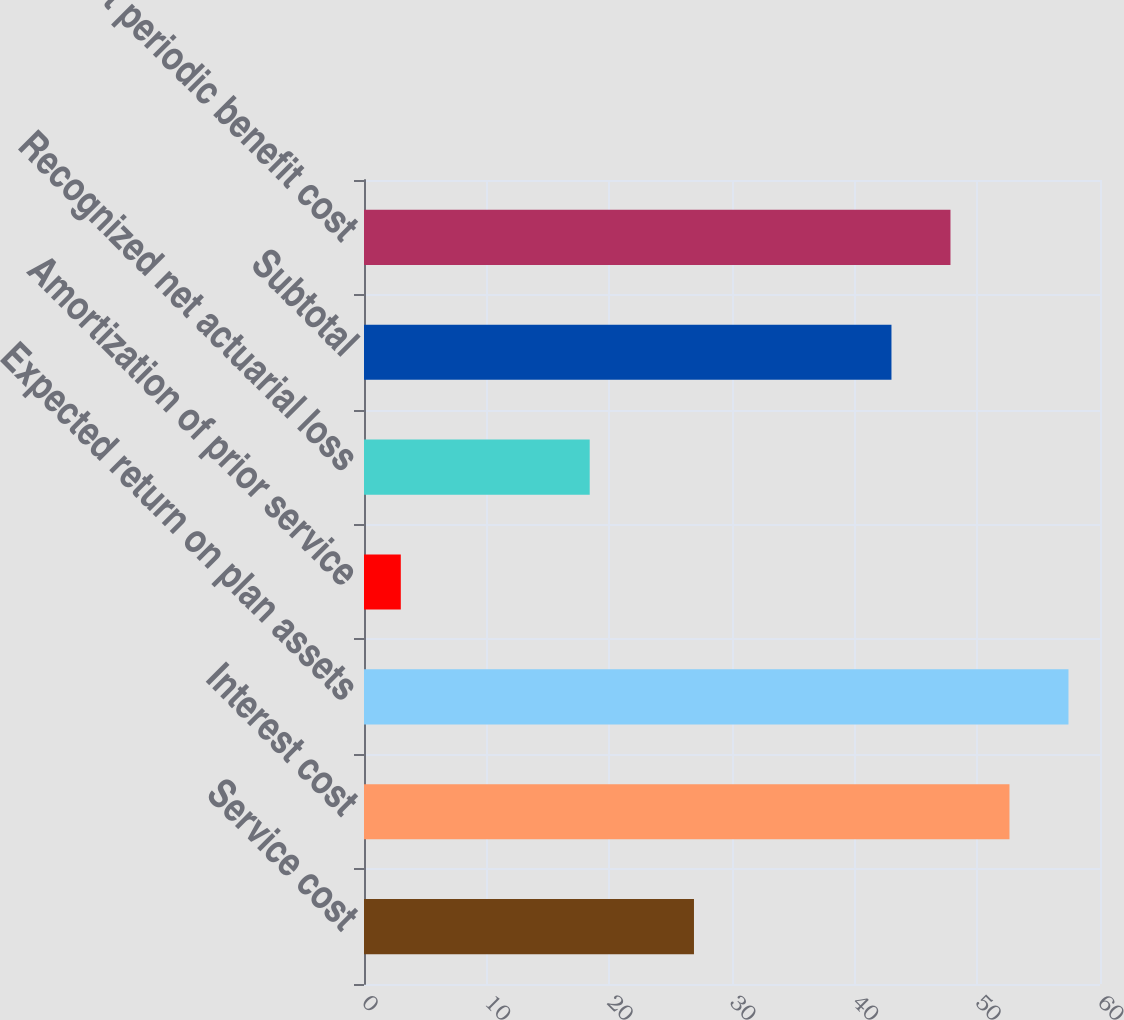<chart> <loc_0><loc_0><loc_500><loc_500><bar_chart><fcel>Service cost<fcel>Interest cost<fcel>Expected return on plan assets<fcel>Amortization of prior service<fcel>Recognized net actuarial loss<fcel>Subtotal<fcel>Net periodic benefit cost<nl><fcel>26.9<fcel>52.62<fcel>57.43<fcel>3<fcel>18.4<fcel>43<fcel>47.81<nl></chart> 